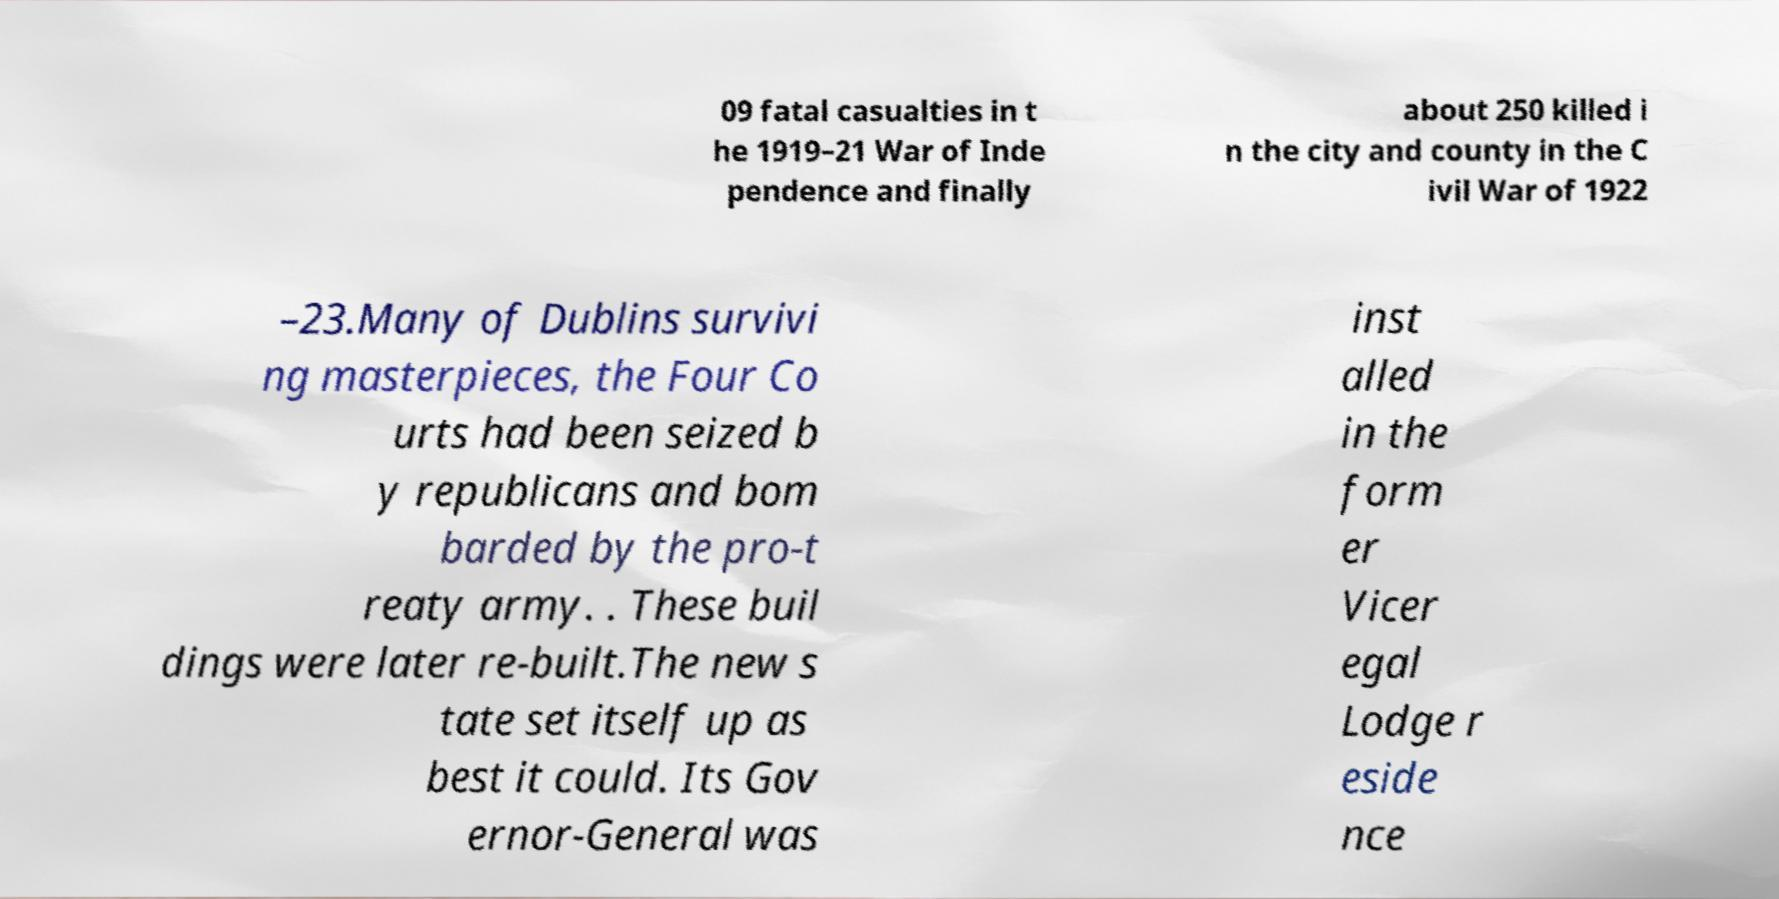There's text embedded in this image that I need extracted. Can you transcribe it verbatim? 09 fatal casualties in t he 1919–21 War of Inde pendence and finally about 250 killed i n the city and county in the C ivil War of 1922 –23.Many of Dublins survivi ng masterpieces, the Four Co urts had been seized b y republicans and bom barded by the pro-t reaty army. . These buil dings were later re-built.The new s tate set itself up as best it could. Its Gov ernor-General was inst alled in the form er Vicer egal Lodge r eside nce 